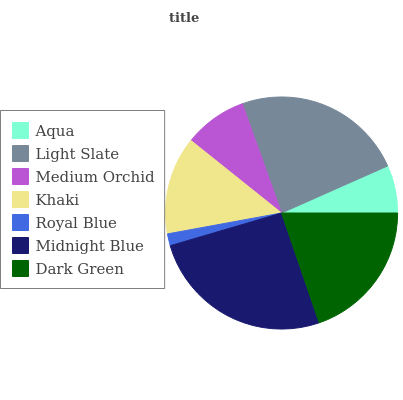Is Royal Blue the minimum?
Answer yes or no. Yes. Is Midnight Blue the maximum?
Answer yes or no. Yes. Is Light Slate the minimum?
Answer yes or no. No. Is Light Slate the maximum?
Answer yes or no. No. Is Light Slate greater than Aqua?
Answer yes or no. Yes. Is Aqua less than Light Slate?
Answer yes or no. Yes. Is Aqua greater than Light Slate?
Answer yes or no. No. Is Light Slate less than Aqua?
Answer yes or no. No. Is Khaki the high median?
Answer yes or no. Yes. Is Khaki the low median?
Answer yes or no. Yes. Is Midnight Blue the high median?
Answer yes or no. No. Is Medium Orchid the low median?
Answer yes or no. No. 